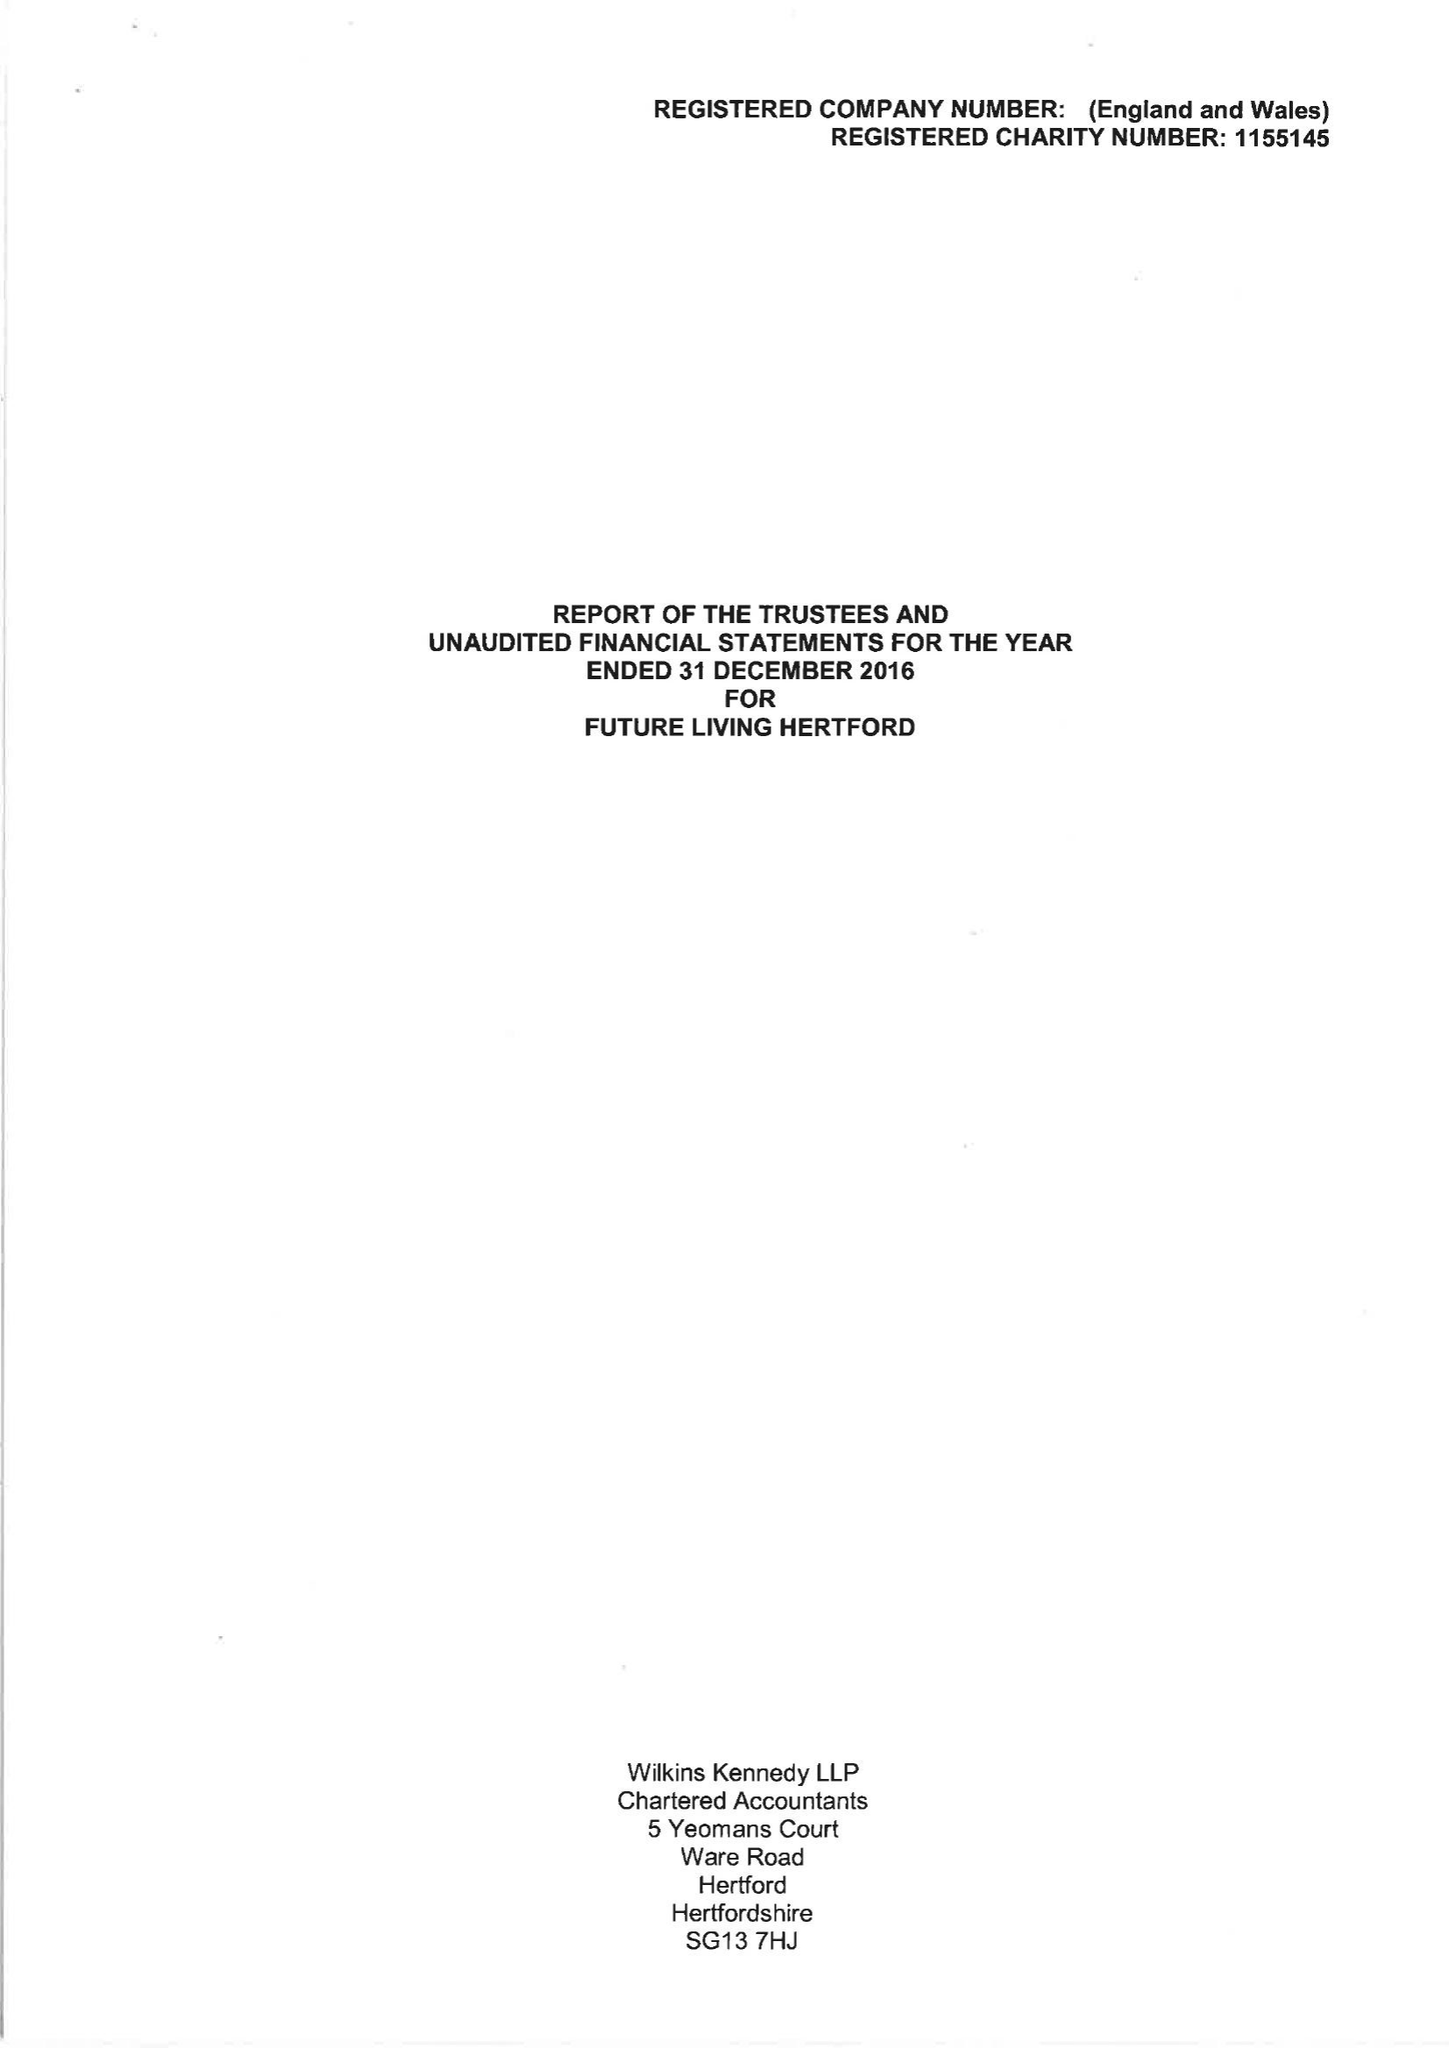What is the value for the charity_number?
Answer the question using a single word or phrase. 1155145 